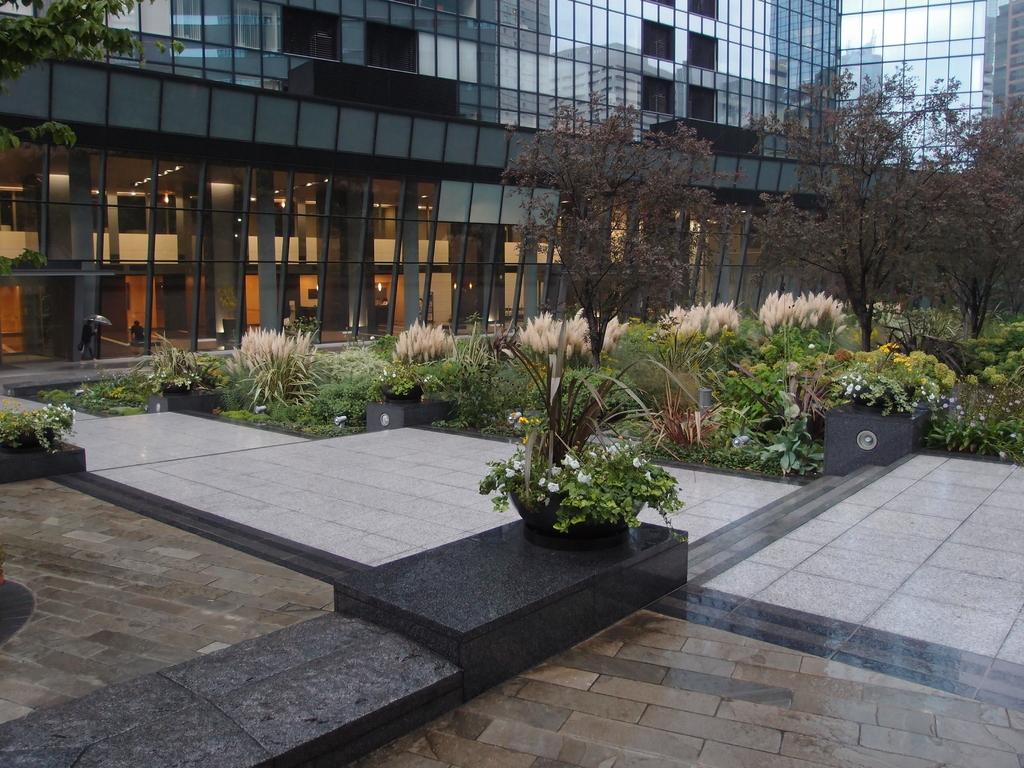In one or two sentences, can you explain what this image depicts? This image is taken outdoors. At the bottom of the image there is a floor. In the background there is a building with walls, windows and glass doors. In the middle of the image there are a few trees and plants on the ground and there are a few plants in the pots. 